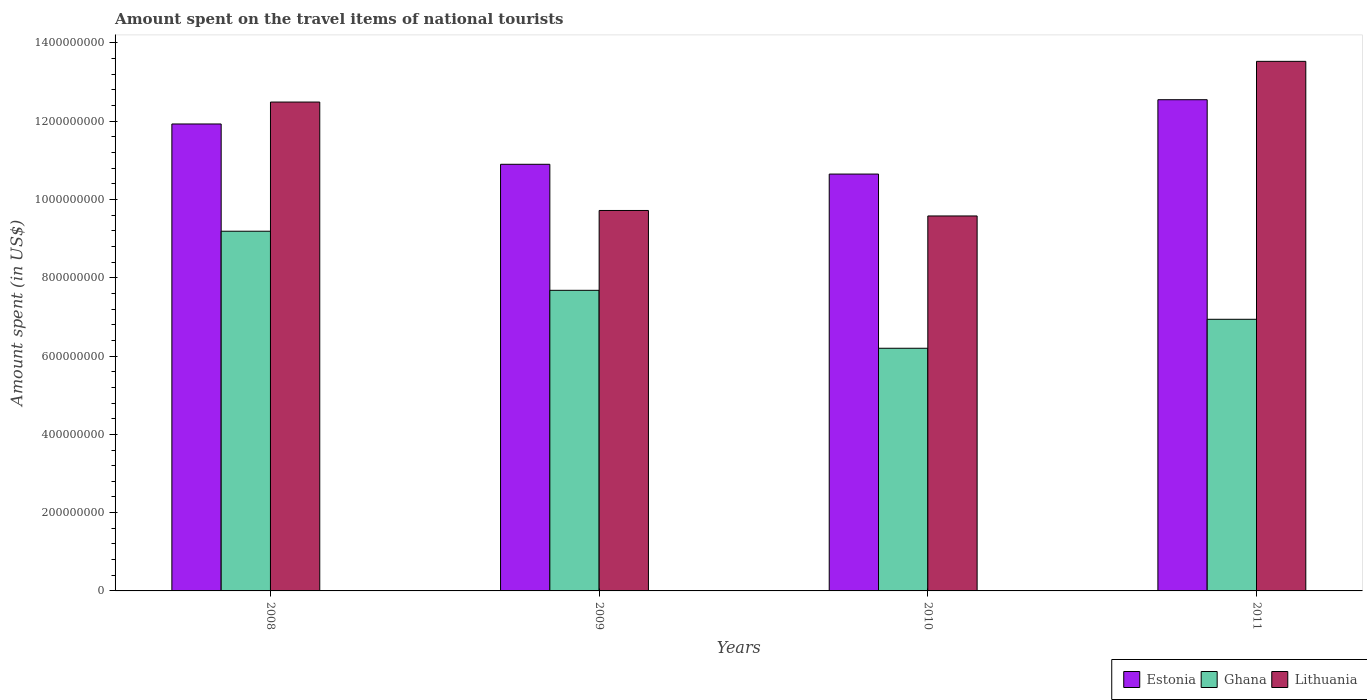How many groups of bars are there?
Your answer should be compact. 4. How many bars are there on the 4th tick from the right?
Make the answer very short. 3. In how many cases, is the number of bars for a given year not equal to the number of legend labels?
Keep it short and to the point. 0. What is the amount spent on the travel items of national tourists in Ghana in 2009?
Your answer should be compact. 7.68e+08. Across all years, what is the maximum amount spent on the travel items of national tourists in Estonia?
Give a very brief answer. 1.26e+09. Across all years, what is the minimum amount spent on the travel items of national tourists in Ghana?
Provide a short and direct response. 6.20e+08. In which year was the amount spent on the travel items of national tourists in Ghana minimum?
Offer a very short reply. 2010. What is the total amount spent on the travel items of national tourists in Lithuania in the graph?
Provide a short and direct response. 4.53e+09. What is the difference between the amount spent on the travel items of national tourists in Ghana in 2010 and that in 2011?
Your response must be concise. -7.40e+07. What is the difference between the amount spent on the travel items of national tourists in Lithuania in 2008 and the amount spent on the travel items of national tourists in Ghana in 2011?
Ensure brevity in your answer.  5.55e+08. What is the average amount spent on the travel items of national tourists in Lithuania per year?
Your answer should be compact. 1.13e+09. In the year 2011, what is the difference between the amount spent on the travel items of national tourists in Ghana and amount spent on the travel items of national tourists in Lithuania?
Provide a succinct answer. -6.59e+08. What is the ratio of the amount spent on the travel items of national tourists in Estonia in 2010 to that in 2011?
Offer a terse response. 0.85. Is the amount spent on the travel items of national tourists in Ghana in 2009 less than that in 2011?
Offer a very short reply. No. Is the difference between the amount spent on the travel items of national tourists in Ghana in 2009 and 2011 greater than the difference between the amount spent on the travel items of national tourists in Lithuania in 2009 and 2011?
Your answer should be compact. Yes. What is the difference between the highest and the second highest amount spent on the travel items of national tourists in Estonia?
Make the answer very short. 6.20e+07. What is the difference between the highest and the lowest amount spent on the travel items of national tourists in Estonia?
Ensure brevity in your answer.  1.90e+08. Is the sum of the amount spent on the travel items of national tourists in Ghana in 2008 and 2009 greater than the maximum amount spent on the travel items of national tourists in Lithuania across all years?
Make the answer very short. Yes. What does the 2nd bar from the left in 2011 represents?
Your response must be concise. Ghana. What does the 1st bar from the right in 2009 represents?
Provide a short and direct response. Lithuania. How many bars are there?
Provide a succinct answer. 12. How many years are there in the graph?
Keep it short and to the point. 4. What is the difference between two consecutive major ticks on the Y-axis?
Offer a very short reply. 2.00e+08. Are the values on the major ticks of Y-axis written in scientific E-notation?
Keep it short and to the point. No. Does the graph contain any zero values?
Ensure brevity in your answer.  No. How are the legend labels stacked?
Your response must be concise. Horizontal. What is the title of the graph?
Offer a very short reply. Amount spent on the travel items of national tourists. What is the label or title of the Y-axis?
Give a very brief answer. Amount spent (in US$). What is the Amount spent (in US$) in Estonia in 2008?
Your answer should be very brief. 1.19e+09. What is the Amount spent (in US$) of Ghana in 2008?
Offer a very short reply. 9.19e+08. What is the Amount spent (in US$) in Lithuania in 2008?
Provide a short and direct response. 1.25e+09. What is the Amount spent (in US$) in Estonia in 2009?
Give a very brief answer. 1.09e+09. What is the Amount spent (in US$) in Ghana in 2009?
Ensure brevity in your answer.  7.68e+08. What is the Amount spent (in US$) of Lithuania in 2009?
Your answer should be compact. 9.72e+08. What is the Amount spent (in US$) in Estonia in 2010?
Your answer should be compact. 1.06e+09. What is the Amount spent (in US$) of Ghana in 2010?
Give a very brief answer. 6.20e+08. What is the Amount spent (in US$) of Lithuania in 2010?
Keep it short and to the point. 9.58e+08. What is the Amount spent (in US$) in Estonia in 2011?
Your answer should be very brief. 1.26e+09. What is the Amount spent (in US$) of Ghana in 2011?
Your response must be concise. 6.94e+08. What is the Amount spent (in US$) in Lithuania in 2011?
Make the answer very short. 1.35e+09. Across all years, what is the maximum Amount spent (in US$) of Estonia?
Your answer should be very brief. 1.26e+09. Across all years, what is the maximum Amount spent (in US$) of Ghana?
Your response must be concise. 9.19e+08. Across all years, what is the maximum Amount spent (in US$) in Lithuania?
Your response must be concise. 1.35e+09. Across all years, what is the minimum Amount spent (in US$) of Estonia?
Offer a very short reply. 1.06e+09. Across all years, what is the minimum Amount spent (in US$) of Ghana?
Make the answer very short. 6.20e+08. Across all years, what is the minimum Amount spent (in US$) of Lithuania?
Your answer should be compact. 9.58e+08. What is the total Amount spent (in US$) in Estonia in the graph?
Offer a terse response. 4.60e+09. What is the total Amount spent (in US$) of Ghana in the graph?
Make the answer very short. 3.00e+09. What is the total Amount spent (in US$) in Lithuania in the graph?
Offer a very short reply. 4.53e+09. What is the difference between the Amount spent (in US$) of Estonia in 2008 and that in 2009?
Your answer should be very brief. 1.03e+08. What is the difference between the Amount spent (in US$) of Ghana in 2008 and that in 2009?
Offer a terse response. 1.51e+08. What is the difference between the Amount spent (in US$) in Lithuania in 2008 and that in 2009?
Provide a short and direct response. 2.77e+08. What is the difference between the Amount spent (in US$) in Estonia in 2008 and that in 2010?
Ensure brevity in your answer.  1.28e+08. What is the difference between the Amount spent (in US$) in Ghana in 2008 and that in 2010?
Ensure brevity in your answer.  2.99e+08. What is the difference between the Amount spent (in US$) of Lithuania in 2008 and that in 2010?
Offer a terse response. 2.91e+08. What is the difference between the Amount spent (in US$) in Estonia in 2008 and that in 2011?
Your answer should be very brief. -6.20e+07. What is the difference between the Amount spent (in US$) in Ghana in 2008 and that in 2011?
Provide a succinct answer. 2.25e+08. What is the difference between the Amount spent (in US$) of Lithuania in 2008 and that in 2011?
Keep it short and to the point. -1.04e+08. What is the difference between the Amount spent (in US$) in Estonia in 2009 and that in 2010?
Offer a terse response. 2.50e+07. What is the difference between the Amount spent (in US$) in Ghana in 2009 and that in 2010?
Your answer should be very brief. 1.48e+08. What is the difference between the Amount spent (in US$) of Lithuania in 2009 and that in 2010?
Your answer should be compact. 1.40e+07. What is the difference between the Amount spent (in US$) in Estonia in 2009 and that in 2011?
Offer a terse response. -1.65e+08. What is the difference between the Amount spent (in US$) in Ghana in 2009 and that in 2011?
Make the answer very short. 7.40e+07. What is the difference between the Amount spent (in US$) of Lithuania in 2009 and that in 2011?
Your answer should be compact. -3.81e+08. What is the difference between the Amount spent (in US$) in Estonia in 2010 and that in 2011?
Your answer should be very brief. -1.90e+08. What is the difference between the Amount spent (in US$) of Ghana in 2010 and that in 2011?
Provide a short and direct response. -7.40e+07. What is the difference between the Amount spent (in US$) of Lithuania in 2010 and that in 2011?
Your response must be concise. -3.95e+08. What is the difference between the Amount spent (in US$) of Estonia in 2008 and the Amount spent (in US$) of Ghana in 2009?
Keep it short and to the point. 4.25e+08. What is the difference between the Amount spent (in US$) of Estonia in 2008 and the Amount spent (in US$) of Lithuania in 2009?
Your response must be concise. 2.21e+08. What is the difference between the Amount spent (in US$) in Ghana in 2008 and the Amount spent (in US$) in Lithuania in 2009?
Provide a succinct answer. -5.30e+07. What is the difference between the Amount spent (in US$) in Estonia in 2008 and the Amount spent (in US$) in Ghana in 2010?
Your answer should be compact. 5.73e+08. What is the difference between the Amount spent (in US$) of Estonia in 2008 and the Amount spent (in US$) of Lithuania in 2010?
Your answer should be very brief. 2.35e+08. What is the difference between the Amount spent (in US$) in Ghana in 2008 and the Amount spent (in US$) in Lithuania in 2010?
Offer a terse response. -3.90e+07. What is the difference between the Amount spent (in US$) of Estonia in 2008 and the Amount spent (in US$) of Ghana in 2011?
Offer a terse response. 4.99e+08. What is the difference between the Amount spent (in US$) of Estonia in 2008 and the Amount spent (in US$) of Lithuania in 2011?
Keep it short and to the point. -1.60e+08. What is the difference between the Amount spent (in US$) of Ghana in 2008 and the Amount spent (in US$) of Lithuania in 2011?
Keep it short and to the point. -4.34e+08. What is the difference between the Amount spent (in US$) in Estonia in 2009 and the Amount spent (in US$) in Ghana in 2010?
Your answer should be compact. 4.70e+08. What is the difference between the Amount spent (in US$) of Estonia in 2009 and the Amount spent (in US$) of Lithuania in 2010?
Make the answer very short. 1.32e+08. What is the difference between the Amount spent (in US$) in Ghana in 2009 and the Amount spent (in US$) in Lithuania in 2010?
Make the answer very short. -1.90e+08. What is the difference between the Amount spent (in US$) in Estonia in 2009 and the Amount spent (in US$) in Ghana in 2011?
Offer a terse response. 3.96e+08. What is the difference between the Amount spent (in US$) in Estonia in 2009 and the Amount spent (in US$) in Lithuania in 2011?
Give a very brief answer. -2.63e+08. What is the difference between the Amount spent (in US$) in Ghana in 2009 and the Amount spent (in US$) in Lithuania in 2011?
Your answer should be very brief. -5.85e+08. What is the difference between the Amount spent (in US$) of Estonia in 2010 and the Amount spent (in US$) of Ghana in 2011?
Make the answer very short. 3.71e+08. What is the difference between the Amount spent (in US$) in Estonia in 2010 and the Amount spent (in US$) in Lithuania in 2011?
Ensure brevity in your answer.  -2.88e+08. What is the difference between the Amount spent (in US$) of Ghana in 2010 and the Amount spent (in US$) of Lithuania in 2011?
Offer a terse response. -7.33e+08. What is the average Amount spent (in US$) of Estonia per year?
Make the answer very short. 1.15e+09. What is the average Amount spent (in US$) of Ghana per year?
Keep it short and to the point. 7.50e+08. What is the average Amount spent (in US$) of Lithuania per year?
Your answer should be very brief. 1.13e+09. In the year 2008, what is the difference between the Amount spent (in US$) of Estonia and Amount spent (in US$) of Ghana?
Offer a terse response. 2.74e+08. In the year 2008, what is the difference between the Amount spent (in US$) in Estonia and Amount spent (in US$) in Lithuania?
Provide a short and direct response. -5.60e+07. In the year 2008, what is the difference between the Amount spent (in US$) of Ghana and Amount spent (in US$) of Lithuania?
Your answer should be compact. -3.30e+08. In the year 2009, what is the difference between the Amount spent (in US$) of Estonia and Amount spent (in US$) of Ghana?
Make the answer very short. 3.22e+08. In the year 2009, what is the difference between the Amount spent (in US$) of Estonia and Amount spent (in US$) of Lithuania?
Give a very brief answer. 1.18e+08. In the year 2009, what is the difference between the Amount spent (in US$) in Ghana and Amount spent (in US$) in Lithuania?
Your response must be concise. -2.04e+08. In the year 2010, what is the difference between the Amount spent (in US$) in Estonia and Amount spent (in US$) in Ghana?
Provide a short and direct response. 4.45e+08. In the year 2010, what is the difference between the Amount spent (in US$) in Estonia and Amount spent (in US$) in Lithuania?
Provide a succinct answer. 1.07e+08. In the year 2010, what is the difference between the Amount spent (in US$) in Ghana and Amount spent (in US$) in Lithuania?
Provide a succinct answer. -3.38e+08. In the year 2011, what is the difference between the Amount spent (in US$) of Estonia and Amount spent (in US$) of Ghana?
Keep it short and to the point. 5.61e+08. In the year 2011, what is the difference between the Amount spent (in US$) in Estonia and Amount spent (in US$) in Lithuania?
Make the answer very short. -9.80e+07. In the year 2011, what is the difference between the Amount spent (in US$) of Ghana and Amount spent (in US$) of Lithuania?
Make the answer very short. -6.59e+08. What is the ratio of the Amount spent (in US$) of Estonia in 2008 to that in 2009?
Provide a succinct answer. 1.09. What is the ratio of the Amount spent (in US$) in Ghana in 2008 to that in 2009?
Your response must be concise. 1.2. What is the ratio of the Amount spent (in US$) in Lithuania in 2008 to that in 2009?
Give a very brief answer. 1.28. What is the ratio of the Amount spent (in US$) in Estonia in 2008 to that in 2010?
Keep it short and to the point. 1.12. What is the ratio of the Amount spent (in US$) of Ghana in 2008 to that in 2010?
Provide a short and direct response. 1.48. What is the ratio of the Amount spent (in US$) of Lithuania in 2008 to that in 2010?
Offer a very short reply. 1.3. What is the ratio of the Amount spent (in US$) of Estonia in 2008 to that in 2011?
Keep it short and to the point. 0.95. What is the ratio of the Amount spent (in US$) of Ghana in 2008 to that in 2011?
Give a very brief answer. 1.32. What is the ratio of the Amount spent (in US$) of Estonia in 2009 to that in 2010?
Provide a succinct answer. 1.02. What is the ratio of the Amount spent (in US$) of Ghana in 2009 to that in 2010?
Keep it short and to the point. 1.24. What is the ratio of the Amount spent (in US$) in Lithuania in 2009 to that in 2010?
Your response must be concise. 1.01. What is the ratio of the Amount spent (in US$) of Estonia in 2009 to that in 2011?
Keep it short and to the point. 0.87. What is the ratio of the Amount spent (in US$) in Ghana in 2009 to that in 2011?
Your response must be concise. 1.11. What is the ratio of the Amount spent (in US$) of Lithuania in 2009 to that in 2011?
Make the answer very short. 0.72. What is the ratio of the Amount spent (in US$) in Estonia in 2010 to that in 2011?
Your answer should be very brief. 0.85. What is the ratio of the Amount spent (in US$) in Ghana in 2010 to that in 2011?
Your answer should be very brief. 0.89. What is the ratio of the Amount spent (in US$) in Lithuania in 2010 to that in 2011?
Your answer should be compact. 0.71. What is the difference between the highest and the second highest Amount spent (in US$) of Estonia?
Make the answer very short. 6.20e+07. What is the difference between the highest and the second highest Amount spent (in US$) of Ghana?
Provide a short and direct response. 1.51e+08. What is the difference between the highest and the second highest Amount spent (in US$) of Lithuania?
Provide a succinct answer. 1.04e+08. What is the difference between the highest and the lowest Amount spent (in US$) of Estonia?
Give a very brief answer. 1.90e+08. What is the difference between the highest and the lowest Amount spent (in US$) in Ghana?
Keep it short and to the point. 2.99e+08. What is the difference between the highest and the lowest Amount spent (in US$) of Lithuania?
Ensure brevity in your answer.  3.95e+08. 